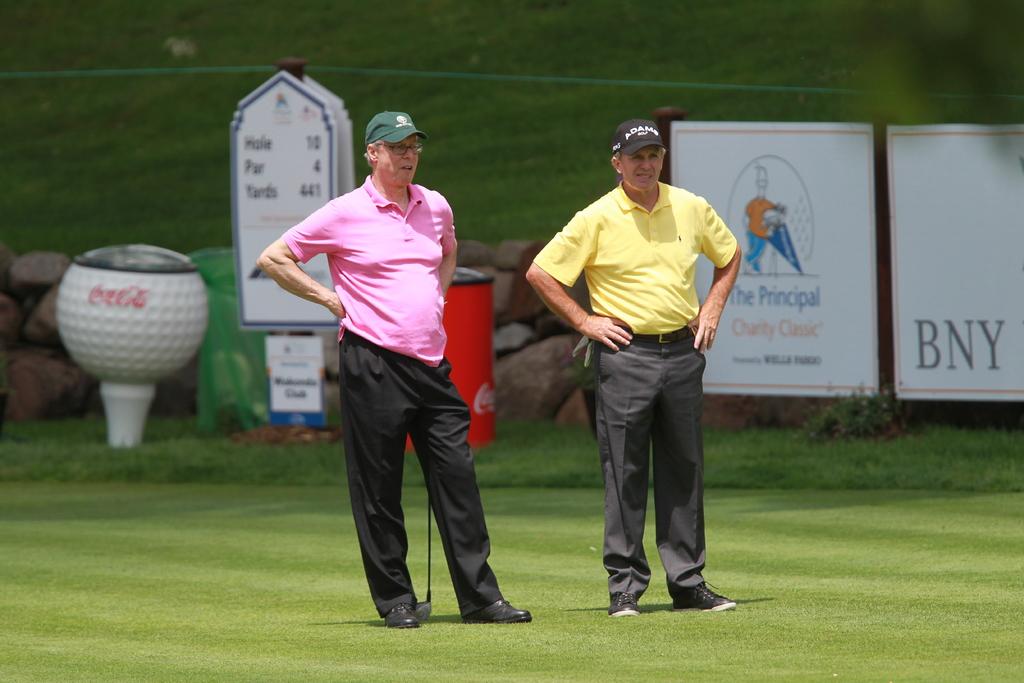What are the three letters on the poster at the far right of the picture?
Ensure brevity in your answer.  Bny. What is one sponsor?
Your answer should be compact. Bny. 